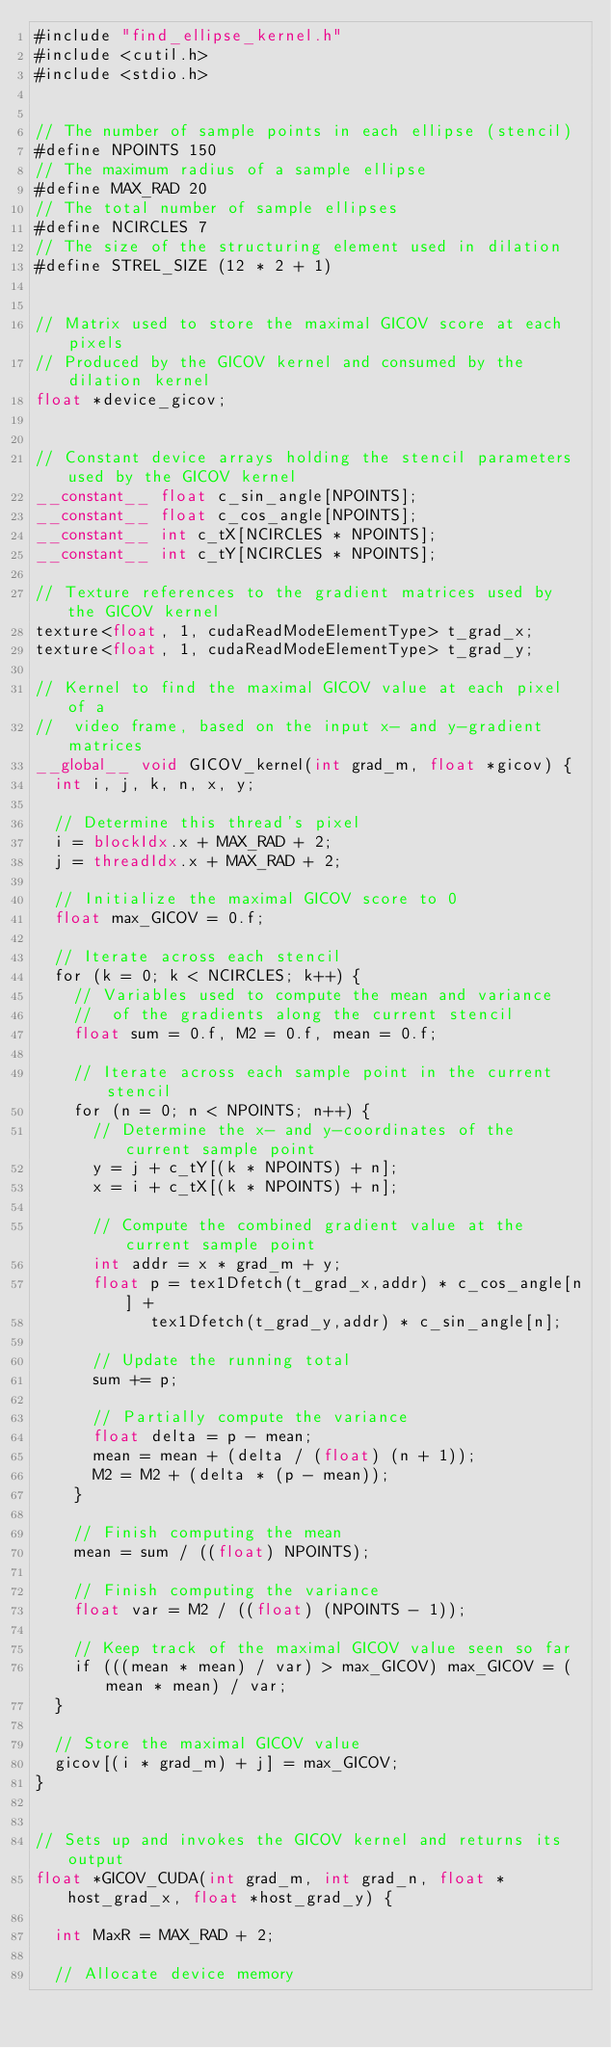Convert code to text. <code><loc_0><loc_0><loc_500><loc_500><_Cuda_>#include "find_ellipse_kernel.h"
#include <cutil.h>
#include <stdio.h>


// The number of sample points in each ellipse (stencil)
#define NPOINTS 150
// The maximum radius of a sample ellipse
#define MAX_RAD 20
// The total number of sample ellipses
#define NCIRCLES 7
// The size of the structuring element used in dilation
#define STREL_SIZE (12 * 2 + 1)


// Matrix used to store the maximal GICOV score at each pixels
// Produced by the GICOV kernel and consumed by the dilation kernel
float *device_gicov;


// Constant device arrays holding the stencil parameters used by the GICOV kernel
__constant__ float c_sin_angle[NPOINTS];
__constant__ float c_cos_angle[NPOINTS];
__constant__ int c_tX[NCIRCLES * NPOINTS];
__constant__ int c_tY[NCIRCLES * NPOINTS];

// Texture references to the gradient matrices used by the GICOV kernel
texture<float, 1, cudaReadModeElementType> t_grad_x;
texture<float, 1, cudaReadModeElementType> t_grad_y;

// Kernel to find the maximal GICOV value at each pixel of a
//  video frame, based on the input x- and y-gradient matrices
__global__ void GICOV_kernel(int grad_m, float *gicov) {
	int i, j, k, n, x, y;
	
	// Determine this thread's pixel
	i = blockIdx.x + MAX_RAD + 2;
	j = threadIdx.x + MAX_RAD + 2;

	// Initialize the maximal GICOV score to 0
	float max_GICOV = 0.f;

	// Iterate across each stencil
	for (k = 0; k < NCIRCLES; k++) {
		// Variables used to compute the mean and variance
		//  of the gradients along the current stencil
		float sum = 0.f, M2 = 0.f, mean = 0.f;		
		
		// Iterate across each sample point in the current stencil
		for (n = 0; n < NPOINTS; n++) {
			// Determine the x- and y-coordinates of the current sample point
			y = j + c_tY[(k * NPOINTS) + n];
			x = i + c_tX[(k * NPOINTS) + n];
			
			// Compute the combined gradient value at the current sample point
			int addr = x * grad_m + y;
			float p = tex1Dfetch(t_grad_x,addr) * c_cos_angle[n] + 
					  tex1Dfetch(t_grad_y,addr) * c_sin_angle[n];
			
			// Update the running total
			sum += p;
			
			// Partially compute the variance
			float delta = p - mean;
			mean = mean + (delta / (float) (n + 1));
			M2 = M2 + (delta * (p - mean));
		}
		
		// Finish computing the mean
		mean = sum / ((float) NPOINTS);
		
		// Finish computing the variance
		float var = M2 / ((float) (NPOINTS - 1));
		
		// Keep track of the maximal GICOV value seen so far
		if (((mean * mean) / var) > max_GICOV) max_GICOV = (mean * mean) / var;
	}
	
	// Store the maximal GICOV value
	gicov[(i * grad_m) + j] = max_GICOV;
}


// Sets up and invokes the GICOV kernel and returns its output
float *GICOV_CUDA(int grad_m, int grad_n, float *host_grad_x, float *host_grad_y) {

	int MaxR = MAX_RAD + 2;

	// Allocate device memory</code> 